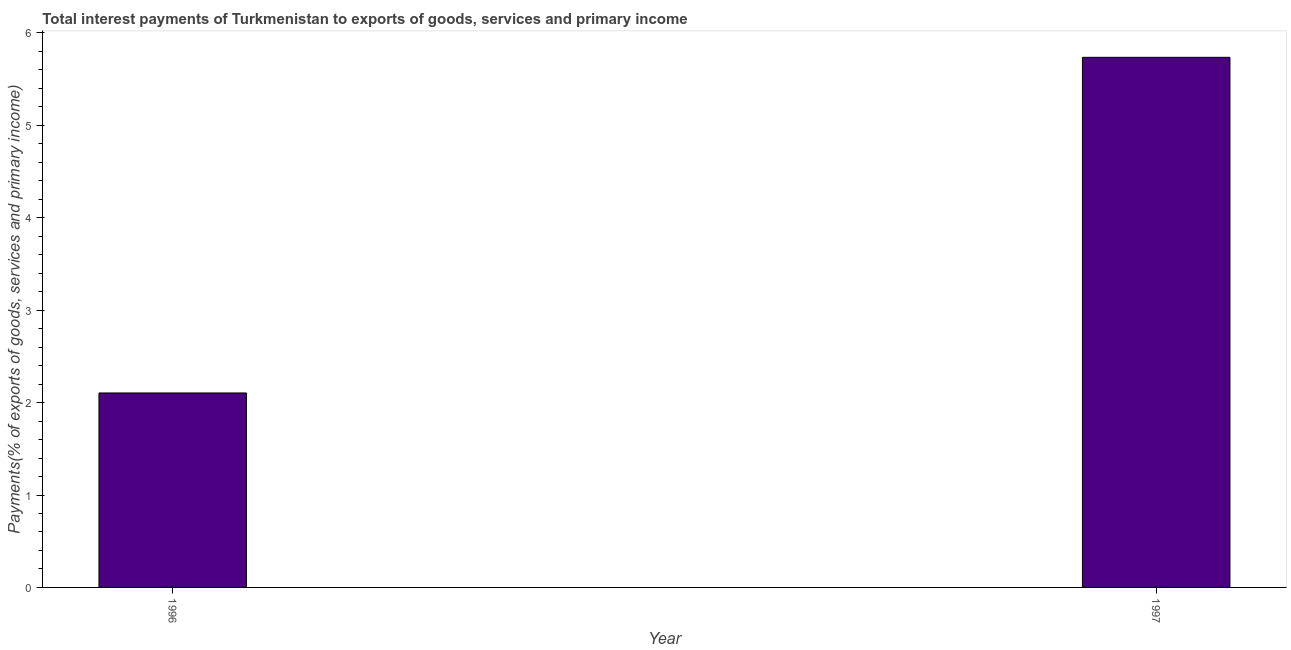What is the title of the graph?
Ensure brevity in your answer.  Total interest payments of Turkmenistan to exports of goods, services and primary income. What is the label or title of the X-axis?
Provide a short and direct response. Year. What is the label or title of the Y-axis?
Give a very brief answer. Payments(% of exports of goods, services and primary income). What is the total interest payments on external debt in 1997?
Offer a terse response. 5.74. Across all years, what is the maximum total interest payments on external debt?
Provide a short and direct response. 5.74. Across all years, what is the minimum total interest payments on external debt?
Make the answer very short. 2.1. In which year was the total interest payments on external debt maximum?
Your answer should be compact. 1997. In which year was the total interest payments on external debt minimum?
Your answer should be compact. 1996. What is the sum of the total interest payments on external debt?
Keep it short and to the point. 7.84. What is the difference between the total interest payments on external debt in 1996 and 1997?
Your response must be concise. -3.63. What is the average total interest payments on external debt per year?
Your answer should be very brief. 3.92. What is the median total interest payments on external debt?
Offer a very short reply. 3.92. In how many years, is the total interest payments on external debt greater than 4 %?
Ensure brevity in your answer.  1. Do a majority of the years between 1997 and 1996 (inclusive) have total interest payments on external debt greater than 2.4 %?
Your answer should be very brief. No. What is the ratio of the total interest payments on external debt in 1996 to that in 1997?
Ensure brevity in your answer.  0.37. In how many years, is the total interest payments on external debt greater than the average total interest payments on external debt taken over all years?
Keep it short and to the point. 1. What is the difference between two consecutive major ticks on the Y-axis?
Your response must be concise. 1. Are the values on the major ticks of Y-axis written in scientific E-notation?
Your answer should be very brief. No. What is the Payments(% of exports of goods, services and primary income) in 1996?
Your response must be concise. 2.1. What is the Payments(% of exports of goods, services and primary income) in 1997?
Ensure brevity in your answer.  5.74. What is the difference between the Payments(% of exports of goods, services and primary income) in 1996 and 1997?
Your answer should be compact. -3.63. What is the ratio of the Payments(% of exports of goods, services and primary income) in 1996 to that in 1997?
Give a very brief answer. 0.37. 